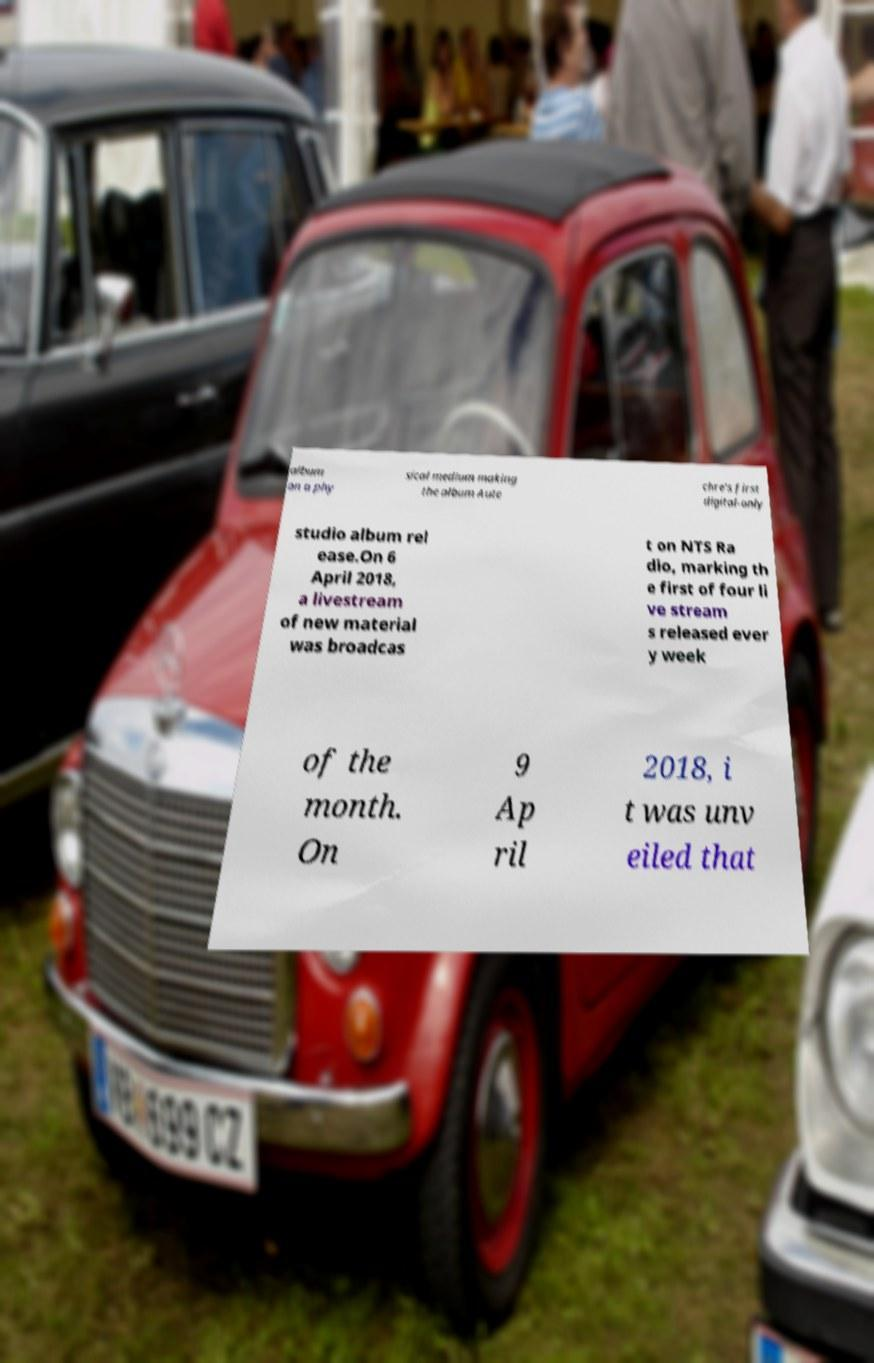For documentation purposes, I need the text within this image transcribed. Could you provide that? album on a phy sical medium making the album Aute chre's first digital-only studio album rel ease.On 6 April 2018, a livestream of new material was broadcas t on NTS Ra dio, marking th e first of four li ve stream s released ever y week of the month. On 9 Ap ril 2018, i t was unv eiled that 